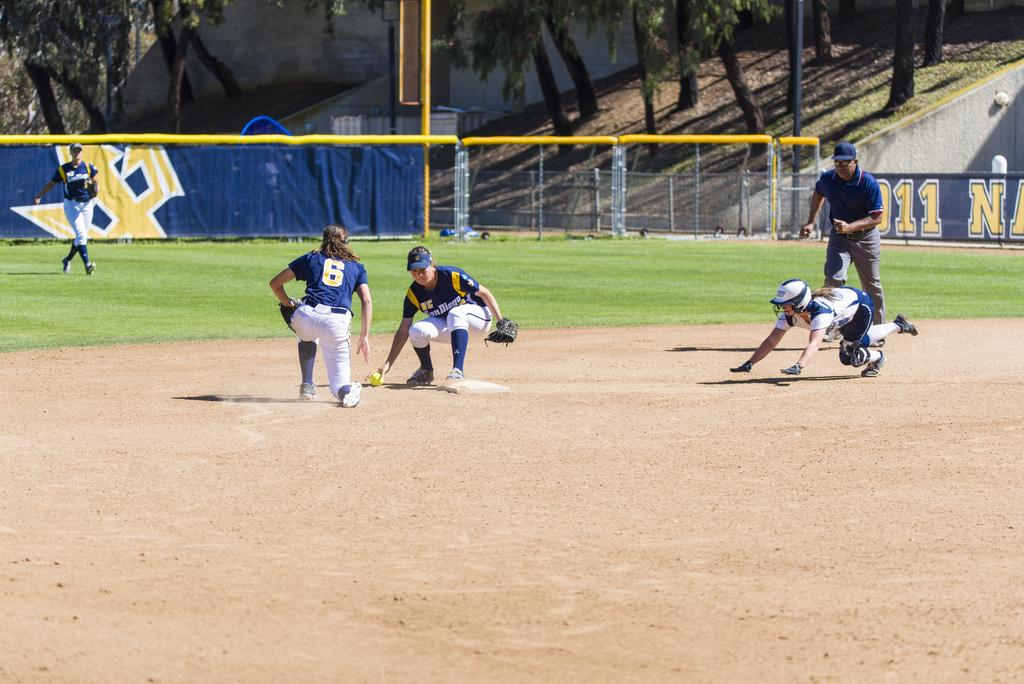<image>
Render a clear and concise summary of the photo. A San Diego softball player is trying to catch a ball while a different player runs towards the base. 